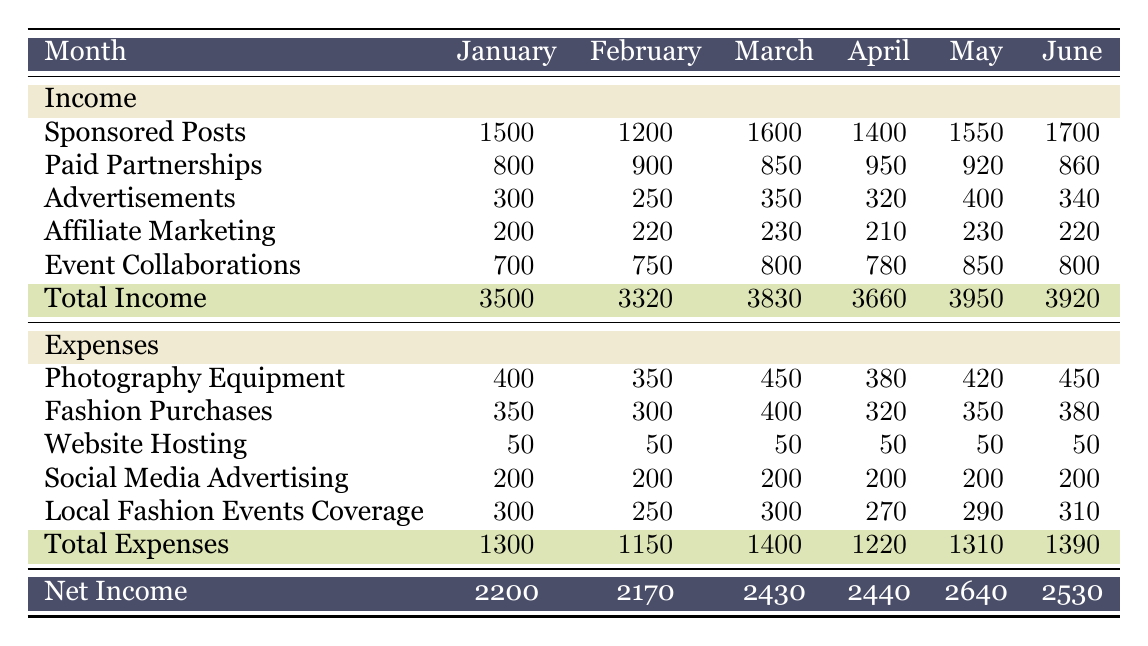What was the total income for March? The total income for March can be found in the "Total Income" row for that month. Looking at the table, it indicates 3830.
Answer: 3830 What were the expenses for Affiliate Marketing in April? The expenses for Affiliate Marketing are listed under the "Expenses" section for the month of April. In April, the value is 210.
Answer: 210 Did the expenses increase from January to February? To answer this, we need to compare the total expenses for January (1300) and February (1150). Since 1300 is greater than 1150, the expenses did not increase.
Answer: No What is the average income from Sponsored Posts for the first six months? To find the average, first sum the Sponsored Posts for each month: 1500 + 1200 + 1600 + 1400 + 1550 + 1700 = 10500. Then divide by 6 to get: 10500 / 6 = 1750.
Answer: 1750 Which month had the highest net income? The net incomes are listed for each month: January (2200), February (2170), March (2430), April (2440), May (2640), June (2530). The highest net income is found in May with a value of 2640.
Answer: May What was the total expense for Photography Equipment over the six months? The expenses for Photography Equipment for each month are: January (400), February (350), March (450), April (380), May (420), June (450). Adding these values gives: 400 + 350 + 450 + 380 + 420 + 450 = 2250.
Answer: 2250 Did the income from Advertisements stay the same throughout these six months? By looking at the amounts for Advertisements: January (300), February (250), March (350), April (320), May (400), June (340), we see they vary, thus they did not stay the same.
Answer: No What is the total net income for the first quarter (January to March)? The net incomes for the first quarter are: January (2200), February (2170), March (2430). Adding these gives: 2200 + 2170 + 2430 = 6800.
Answer: 6800 Which month had the lowest total expenses, and what was that amount? The total expenses for each month are: January (1300), February (1150), March (1400), April (1220), May (1310), June (1390). The lowest total expenses were in February with a value of 1150.
Answer: February, 1150 